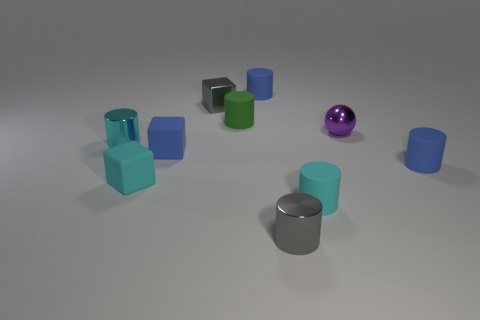Subtract 2 cylinders. How many cylinders are left? 4 Subtract all small metal cylinders. How many cylinders are left? 4 Subtract all gray cylinders. How many cylinders are left? 5 Subtract all green cylinders. Subtract all purple cubes. How many cylinders are left? 5 Subtract all cylinders. How many objects are left? 4 Subtract all brown balls. Subtract all small green objects. How many objects are left? 9 Add 6 cyan shiny objects. How many cyan shiny objects are left? 7 Add 6 tiny blue things. How many tiny blue things exist? 9 Subtract 1 purple spheres. How many objects are left? 9 